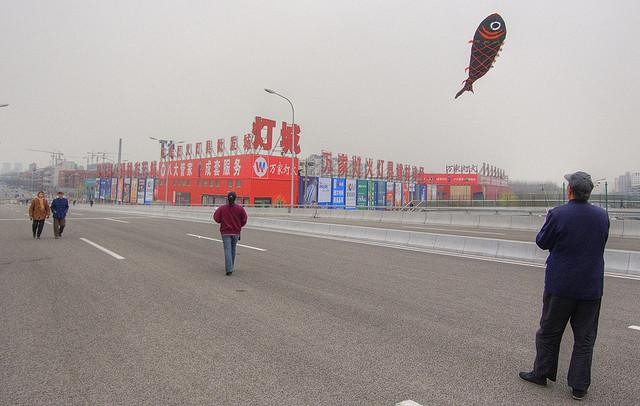What is the giant fish in the air? kite 